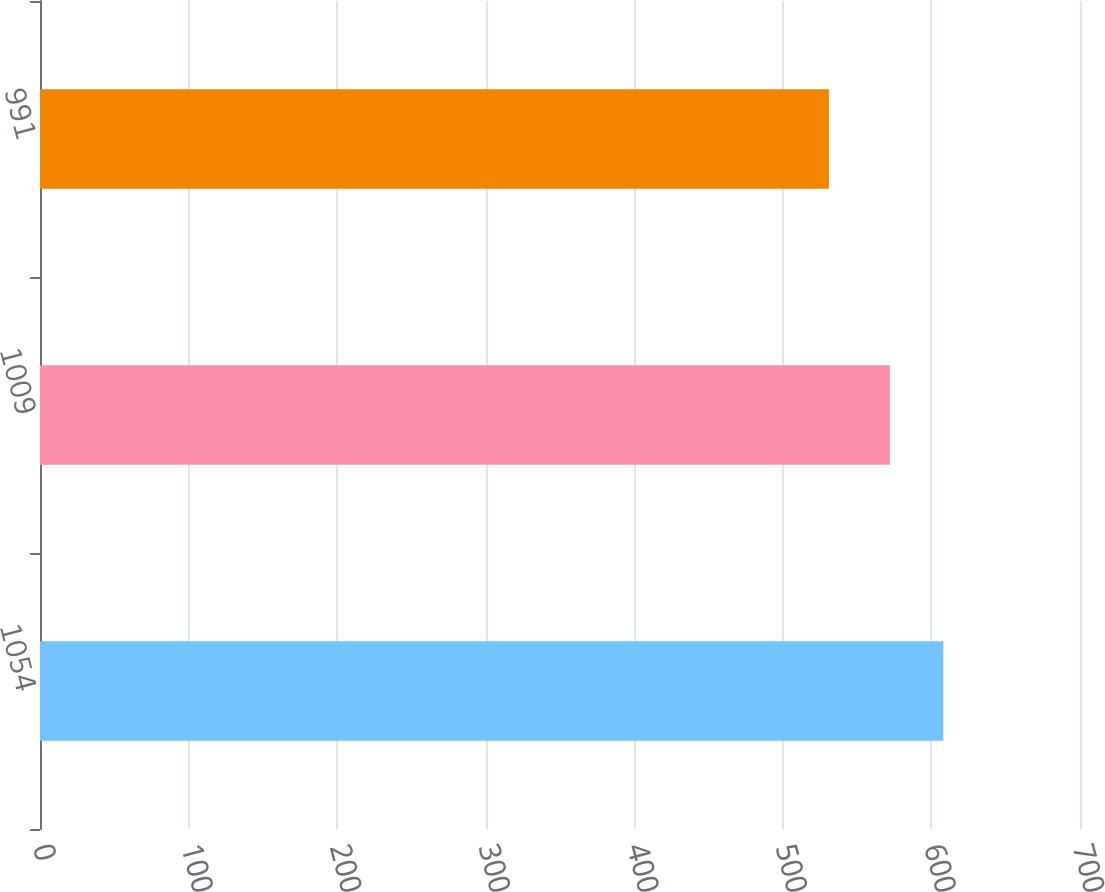<chart> <loc_0><loc_0><loc_500><loc_500><bar_chart><fcel>1054<fcel>1009<fcel>991<nl><fcel>608<fcel>572<fcel>531<nl></chart> 